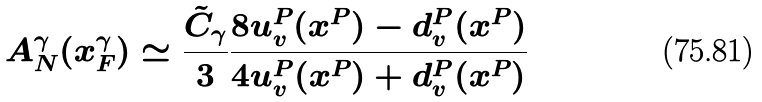Convert formula to latex. <formula><loc_0><loc_0><loc_500><loc_500>A ^ { \gamma } _ { N } ( x ^ { \gamma } _ { F } ) \simeq \frac { \tilde { C } _ { \gamma } } { 3 } \frac { 8 u ^ { P } _ { v } ( x ^ { P } ) - d ^ { P } _ { v } ( x ^ { P } ) } { 4 u ^ { P } _ { v } ( x ^ { P } ) + d ^ { P } _ { v } ( x ^ { P } ) }</formula> 